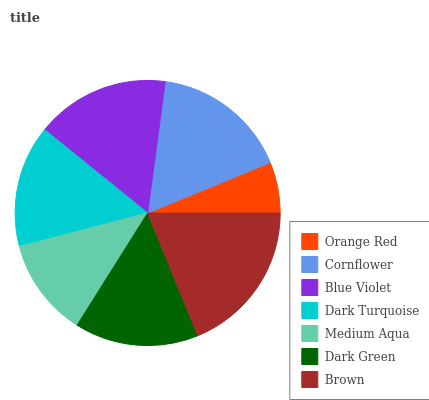Is Orange Red the minimum?
Answer yes or no. Yes. Is Brown the maximum?
Answer yes or no. Yes. Is Cornflower the minimum?
Answer yes or no. No. Is Cornflower the maximum?
Answer yes or no. No. Is Cornflower greater than Orange Red?
Answer yes or no. Yes. Is Orange Red less than Cornflower?
Answer yes or no. Yes. Is Orange Red greater than Cornflower?
Answer yes or no. No. Is Cornflower less than Orange Red?
Answer yes or no. No. Is Dark Green the high median?
Answer yes or no. Yes. Is Dark Green the low median?
Answer yes or no. Yes. Is Medium Aqua the high median?
Answer yes or no. No. Is Blue Violet the low median?
Answer yes or no. No. 